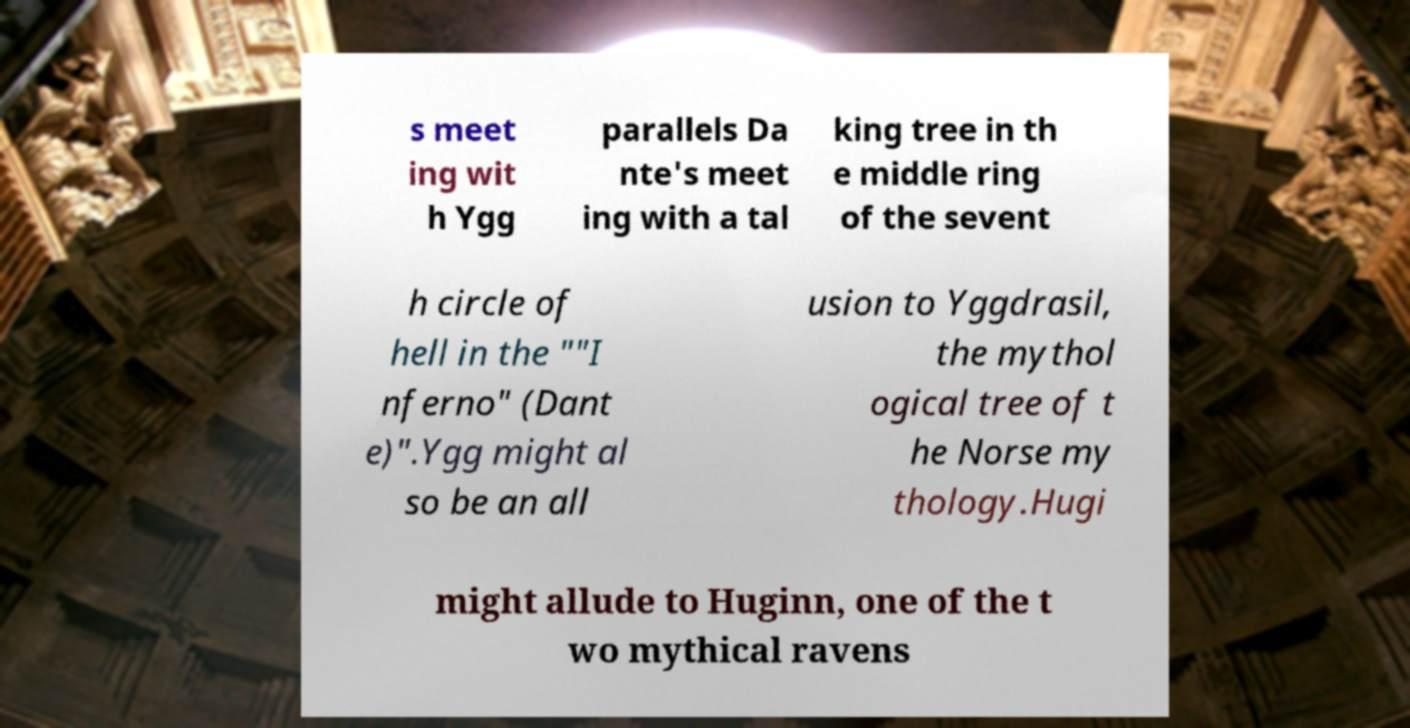I need the written content from this picture converted into text. Can you do that? s meet ing wit h Ygg parallels Da nte's meet ing with a tal king tree in th e middle ring of the sevent h circle of hell in the ""I nferno" (Dant e)".Ygg might al so be an all usion to Yggdrasil, the mythol ogical tree of t he Norse my thology.Hugi might allude to Huginn, one of the t wo mythical ravens 